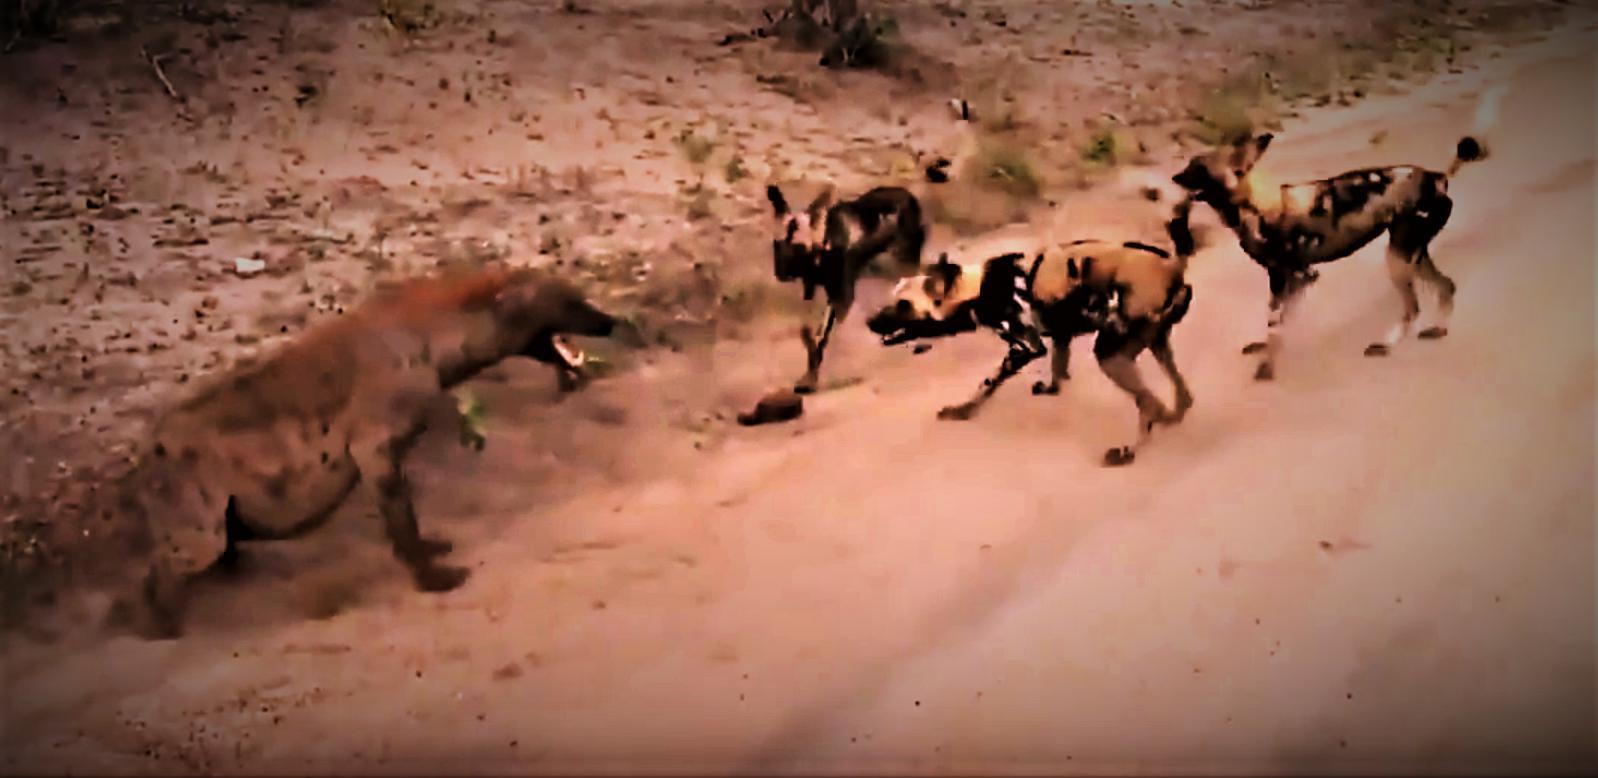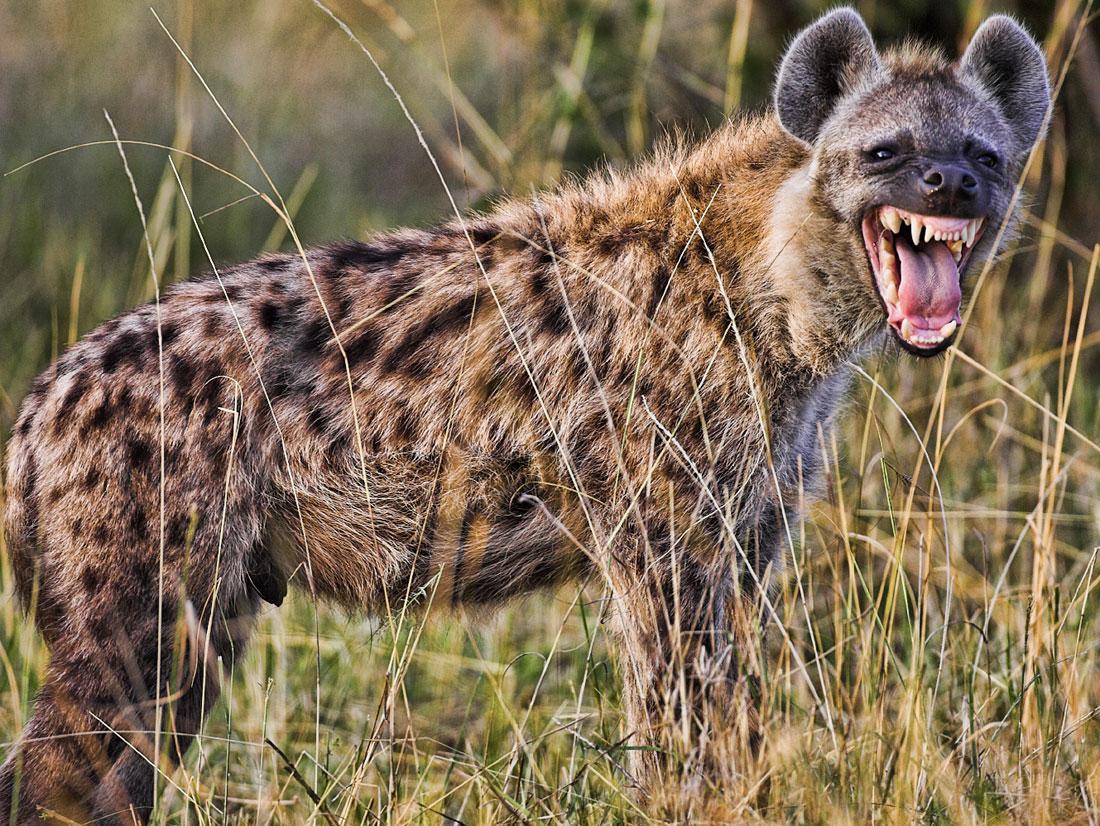The first image is the image on the left, the second image is the image on the right. Assess this claim about the two images: "There is at least one hyena with its mouth closed.". Correct or not? Answer yes or no. No. 